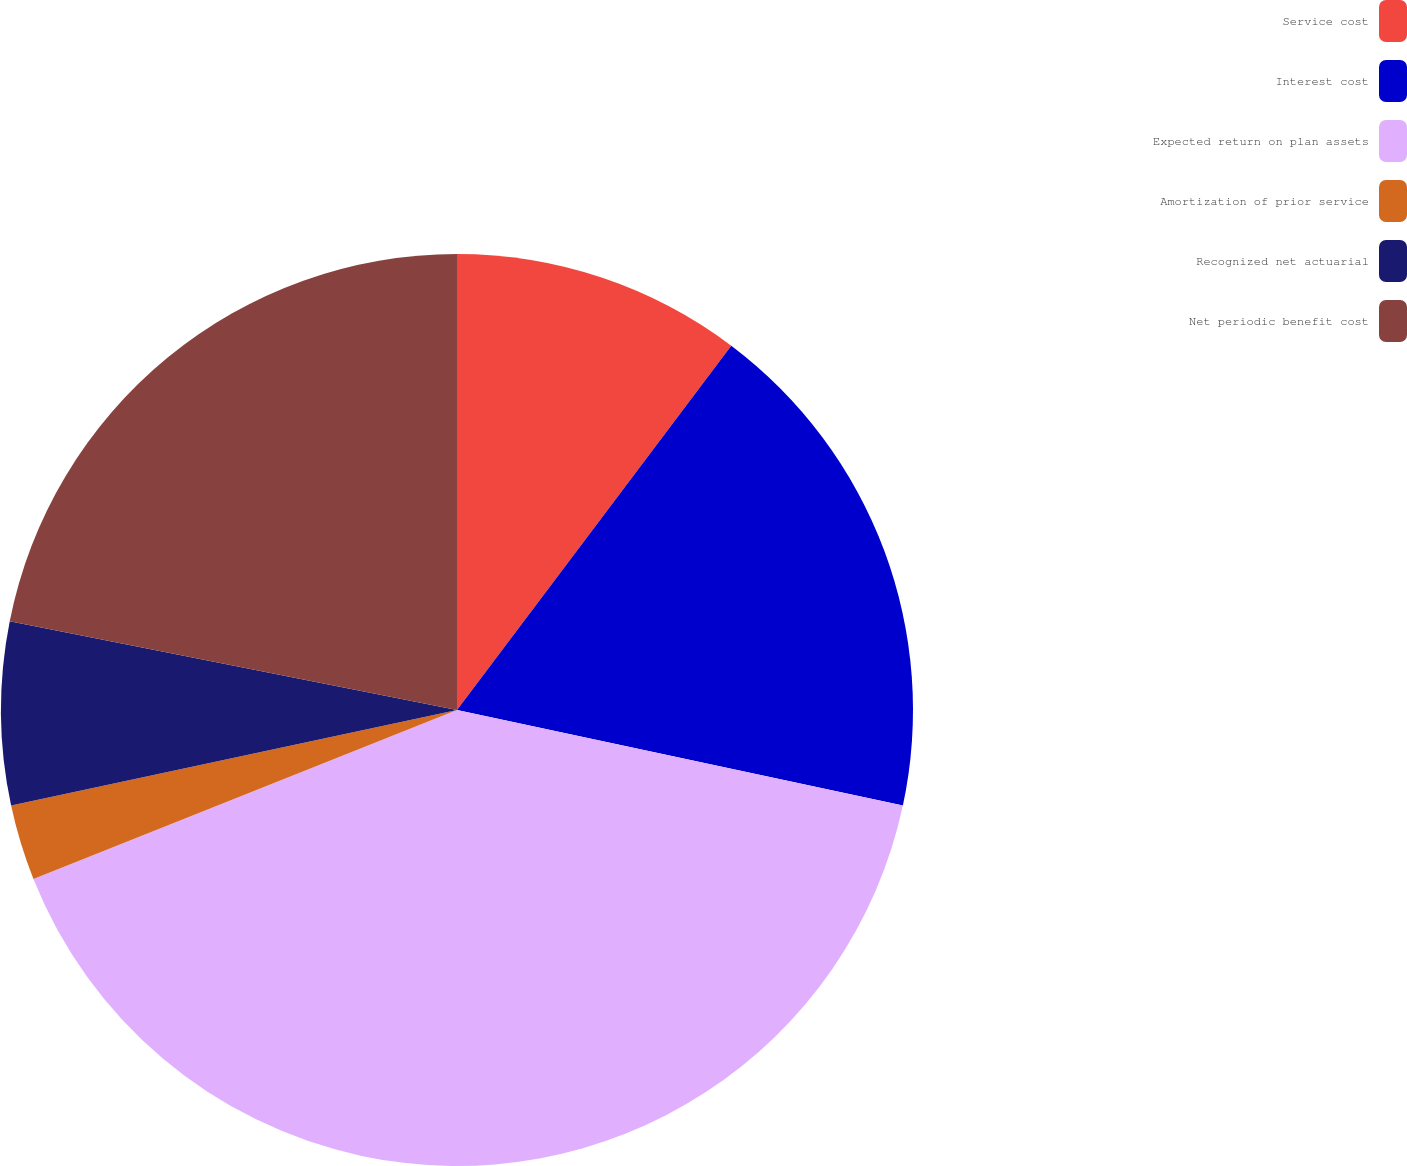Convert chart. <chart><loc_0><loc_0><loc_500><loc_500><pie_chart><fcel>Service cost<fcel>Interest cost<fcel>Expected return on plan assets<fcel>Amortization of prior service<fcel>Recognized net actuarial<fcel>Net periodic benefit cost<nl><fcel>10.27%<fcel>18.09%<fcel>40.6%<fcel>2.68%<fcel>6.48%<fcel>21.88%<nl></chart> 